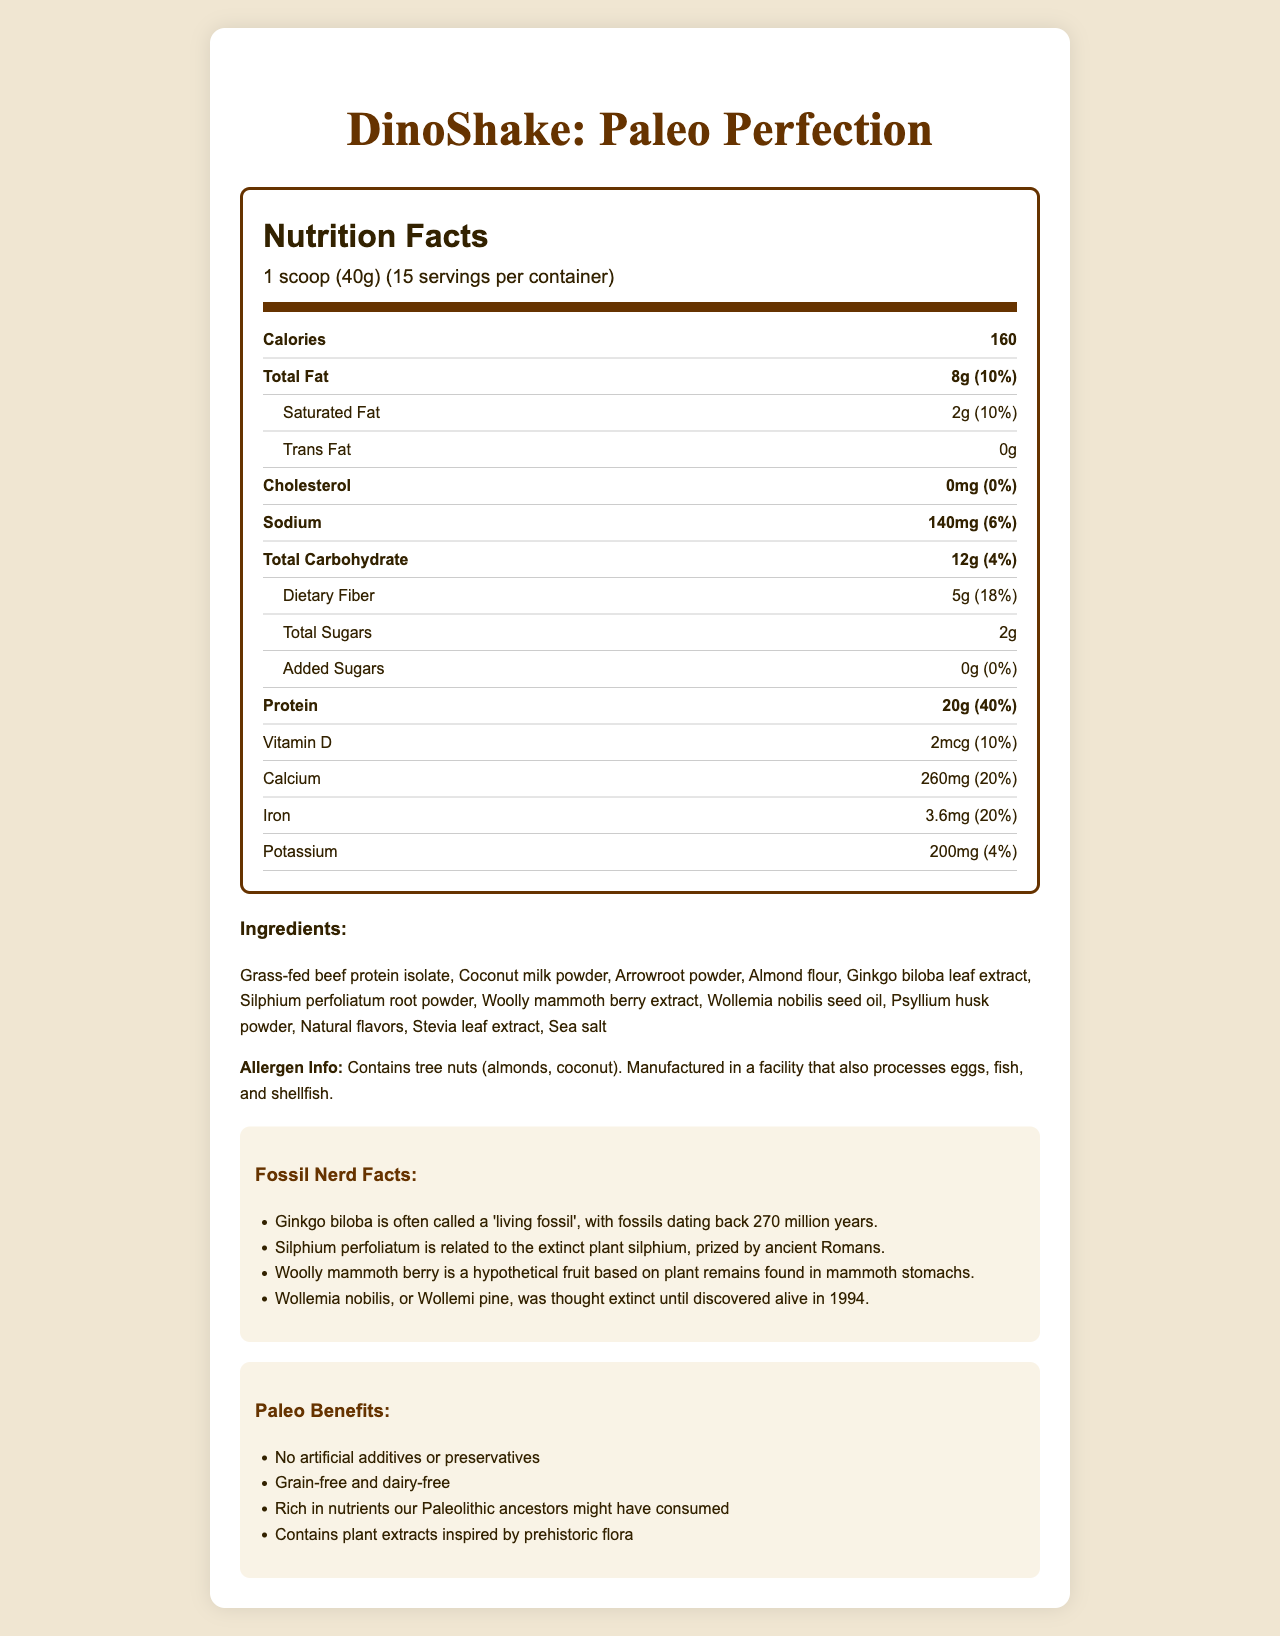what is the serving size? The serving size is explicitly mentioned at the top under the product name "DinoShake: Paleo Perfection".
Answer: 1 scoop (40g) how many calories are there per serving? The document specifies 160 calories per serving in the nutrition facts section.
Answer: 160 what is the total fat content per serving? The total fat content per serving is listed as 8g in the nutrition facts section.
Answer: 8g how much protein does one serving provide? The nutrition facts label lists the protein content as 20g per serving.
Answer: 20g is there any cholesterol in this product? The nutrition facts show 0mg cholesterol, which indicates there is no cholesterol in the product.
Answer: No how many servings are there per container? A. 10 B. 15 C. 20 The serving size information states that there are 15 servings per container.
Answer: B which of the following is a "living fossil" mentioned in the ingredient list? I. Ginkgo biloba II. Woolly mammoth berry III. Wollemia nobilis Ginkgo biloba is described as a "living fossil" with fossils dating back 270 million years.
Answer: I does this product contain any artificial additives or preservatives? According to the paleo benefits section, the product has no artificial additives or preservatives.
Answer: No how much dietary fiber is in each serving? The nutrition facts label lists dietary fiber as 5g per serving.
Answer: 5g does this product contain tree nuts? The allergen information state that it contains tree nuts (almonds, coconut).
Answer: Yes describe the main idea of the document. The document includes a comprehensive breakdown of the product's nutritional information, unique ingredients, and historical facts related to some ingredients, emphasizing its suitability for a paleo diet.
Answer: The document provides a detailed overview of the "DinoShake: Paleo Perfection" meal replacement shake, including its nutrition facts, ingredient list, allergen information, fossil nerd facts, and paleo diet benefits. which vitamin is provided in the smallest amount? A. Vitamin D B. Calcium C. Iron D. Potassium The nutrition facts show that Vitamin D is provided in an amount of 2mcg, which is smaller compared to the other listed vitamins and minerals.
Answer: A can the exact source of the "natural flavors" be determined from the document? The document lists "natural flavors" as an ingredient, but does not specify the exact sources or components of these natural flavors.
Answer: Cannot be determined how much sodium does one serving contain? According to the nutrition facts, one serving contains 140mg of sodium.
Answer: 140mg what extinct plant is the Silphium perfoliatum related to? The fossil nerd facts mention that Silphium perfoliatum is related to the extinct plant silphium, which was prized by ancient Romans.
Answer: Silphium 